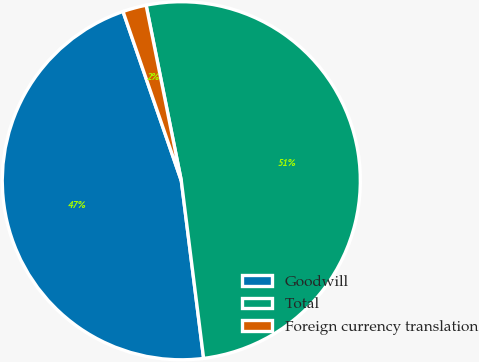Convert chart. <chart><loc_0><loc_0><loc_500><loc_500><pie_chart><fcel>Goodwill<fcel>Total<fcel>Foreign currency translation<nl><fcel>46.71%<fcel>51.16%<fcel>2.13%<nl></chart> 